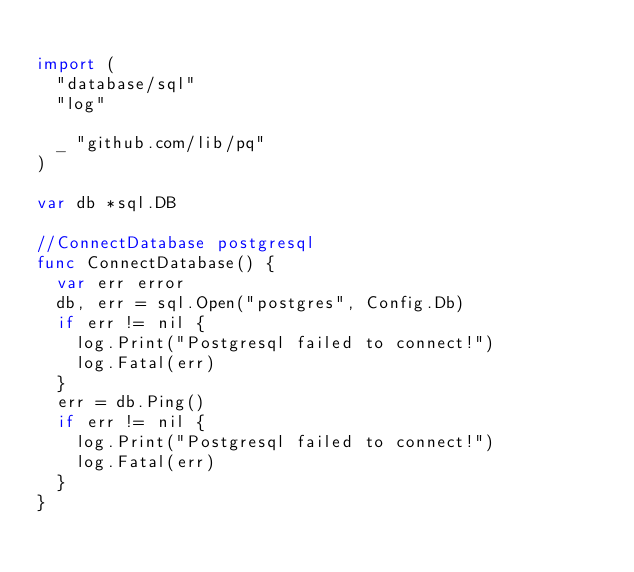<code> <loc_0><loc_0><loc_500><loc_500><_Go_>
import (
	"database/sql"
	"log"

	_ "github.com/lib/pq"
)

var db *sql.DB

//ConnectDatabase postgresql
func ConnectDatabase() {
	var err error
	db, err = sql.Open("postgres", Config.Db)
	if err != nil {
		log.Print("Postgresql failed to connect!")
		log.Fatal(err)
	}
	err = db.Ping()
	if err != nil {
		log.Print("Postgresql failed to connect!")
		log.Fatal(err)
	}
}
</code> 